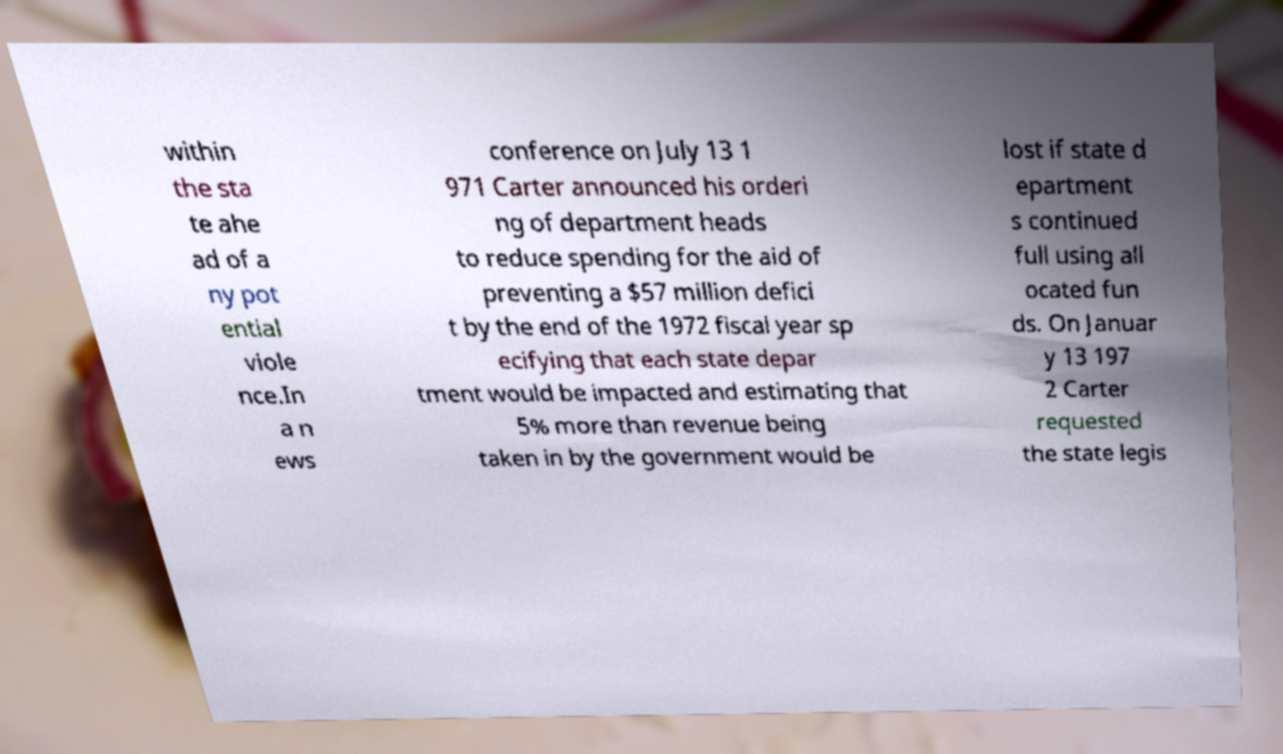What messages or text are displayed in this image? I need them in a readable, typed format. within the sta te ahe ad of a ny pot ential viole nce.In a n ews conference on July 13 1 971 Carter announced his orderi ng of department heads to reduce spending for the aid of preventing a $57 million defici t by the end of the 1972 fiscal year sp ecifying that each state depar tment would be impacted and estimating that 5% more than revenue being taken in by the government would be lost if state d epartment s continued full using all ocated fun ds. On Januar y 13 197 2 Carter requested the state legis 